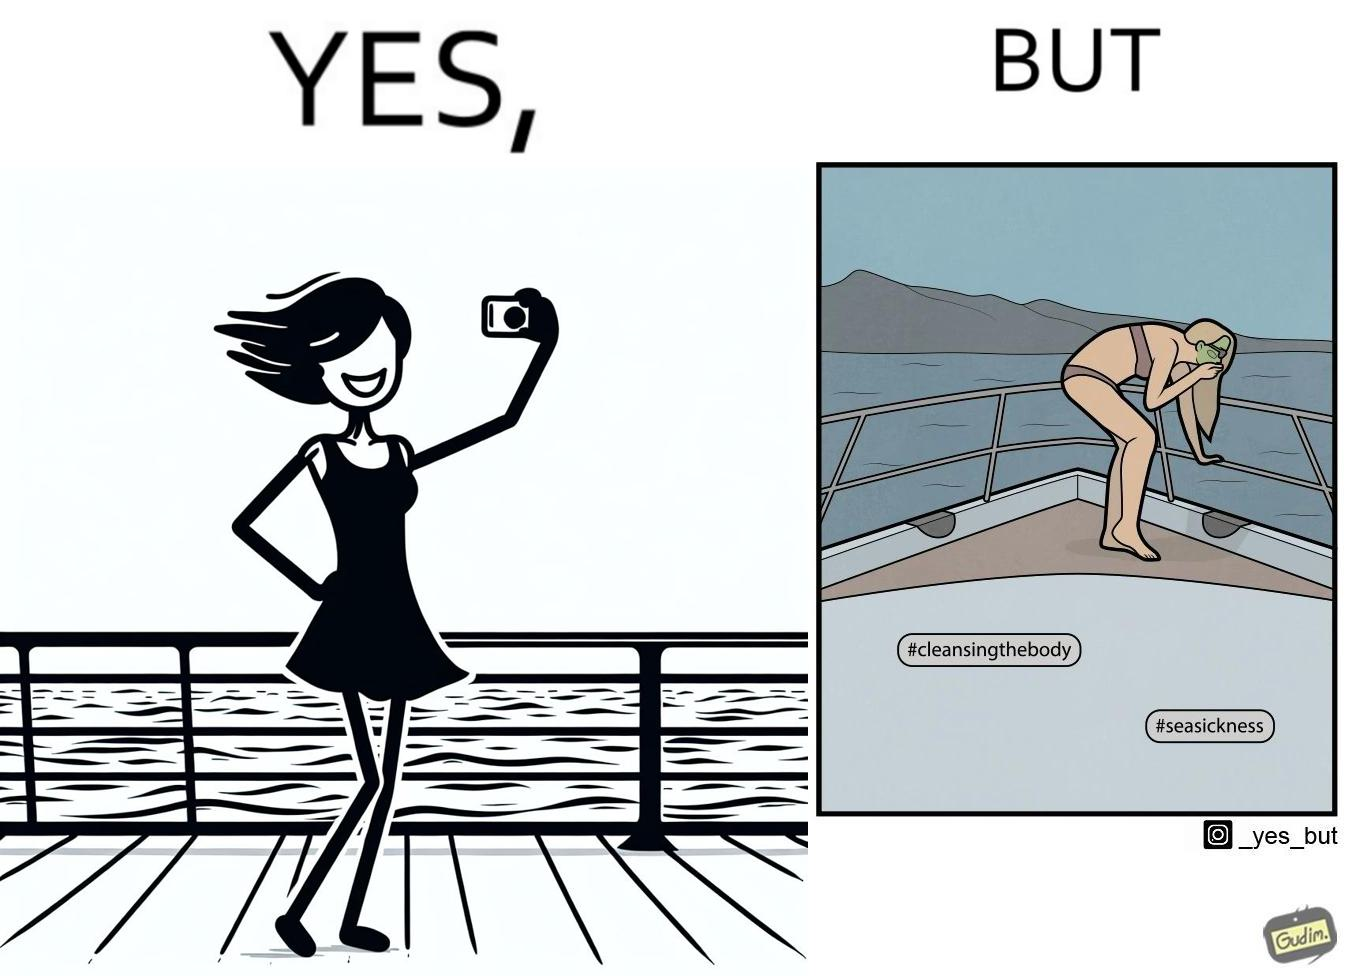Is there satirical content in this image? Yes, this image is satirical. 